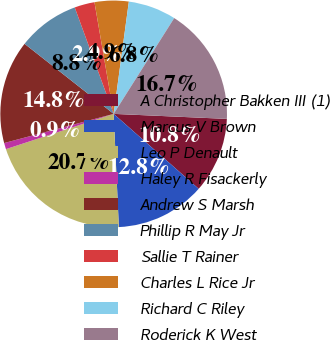Convert chart. <chart><loc_0><loc_0><loc_500><loc_500><pie_chart><fcel>A Christopher Bakken III (1)<fcel>Marcus V Brown<fcel>Leo P Denault<fcel>Haley R Fisackerly<fcel>Andrew S Marsh<fcel>Phillip R May Jr<fcel>Sallie T Rainer<fcel>Charles L Rice Jr<fcel>Richard C Riley<fcel>Roderick K West<nl><fcel>10.79%<fcel>12.77%<fcel>20.69%<fcel>0.89%<fcel>14.75%<fcel>8.81%<fcel>2.87%<fcel>4.85%<fcel>6.83%<fcel>16.73%<nl></chart> 